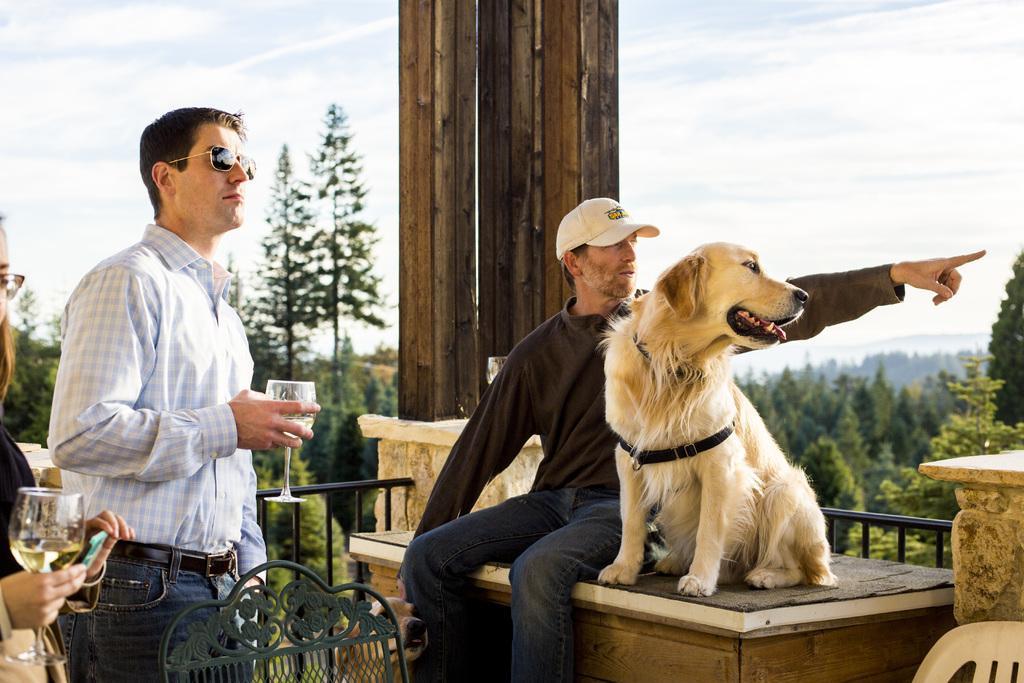Could you give a brief overview of what you see in this image? There is a man and a dog on the desk in the foreground area of the image, there are people, by holding glasses in their hands on the left side and there are chairs at the bottom side. There are boundaries, trees, sky, it seems like a wooden pillar in the background area. 